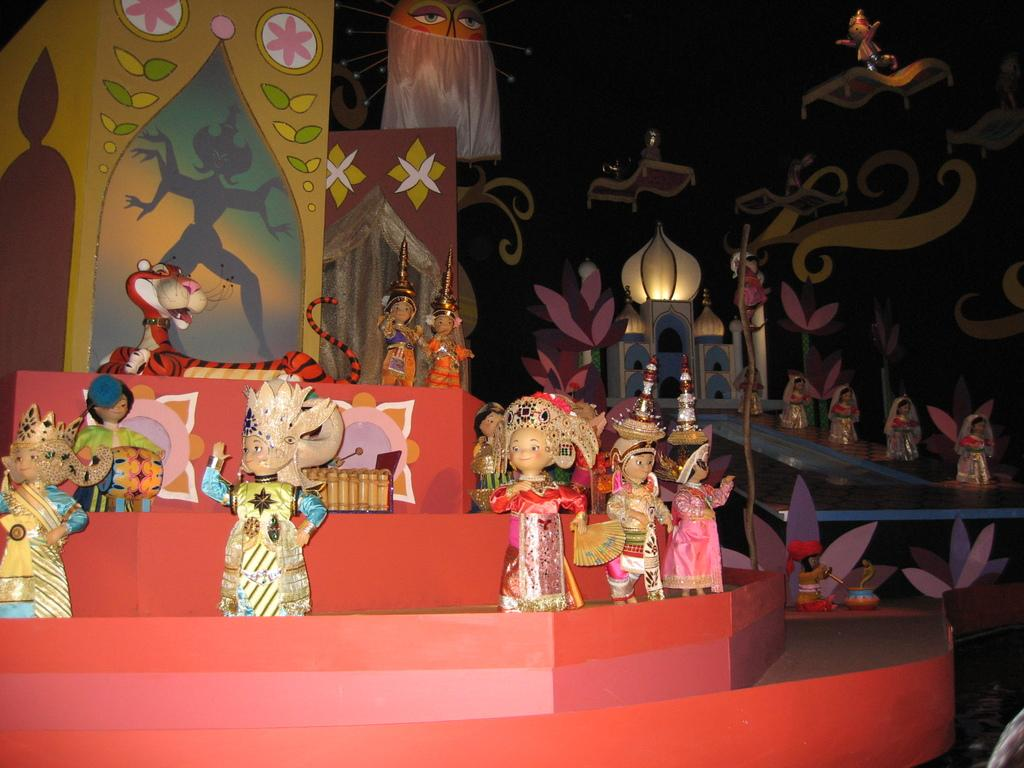What can be seen in the image related to decorations? There are decorations in the image, and they are placed in rows on a table. How are the decorations arranged on the table? The decorations are arranged in rows on the table. What type of pies are being served with the decorations in the image? There is no mention of pies in the image; the focus is on the decorations arranged in rows on the table. 